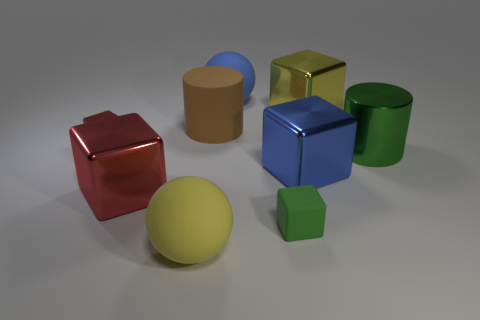Subtract 2 cubes. How many cubes are left? 3 Subtract all tiny rubber blocks. How many blocks are left? 4 Add 1 cylinders. How many objects exist? 10 Subtract all blocks. How many objects are left? 4 Add 3 red blocks. How many red blocks are left? 5 Add 6 blue rubber things. How many blue rubber things exist? 7 Subtract 0 gray cylinders. How many objects are left? 9 Subtract all tiny purple things. Subtract all large yellow rubber balls. How many objects are left? 8 